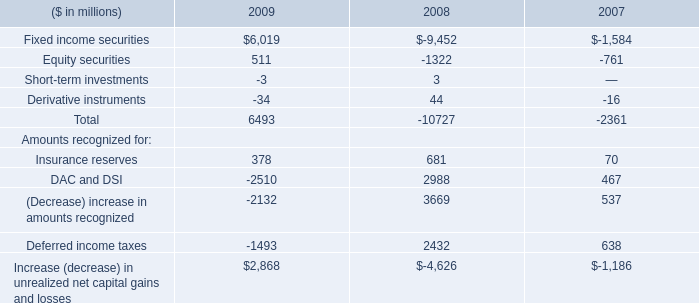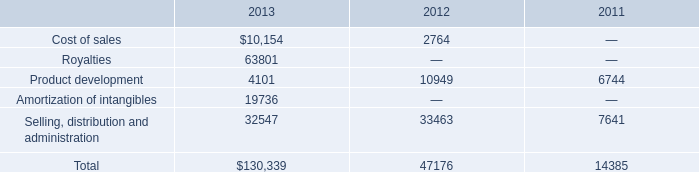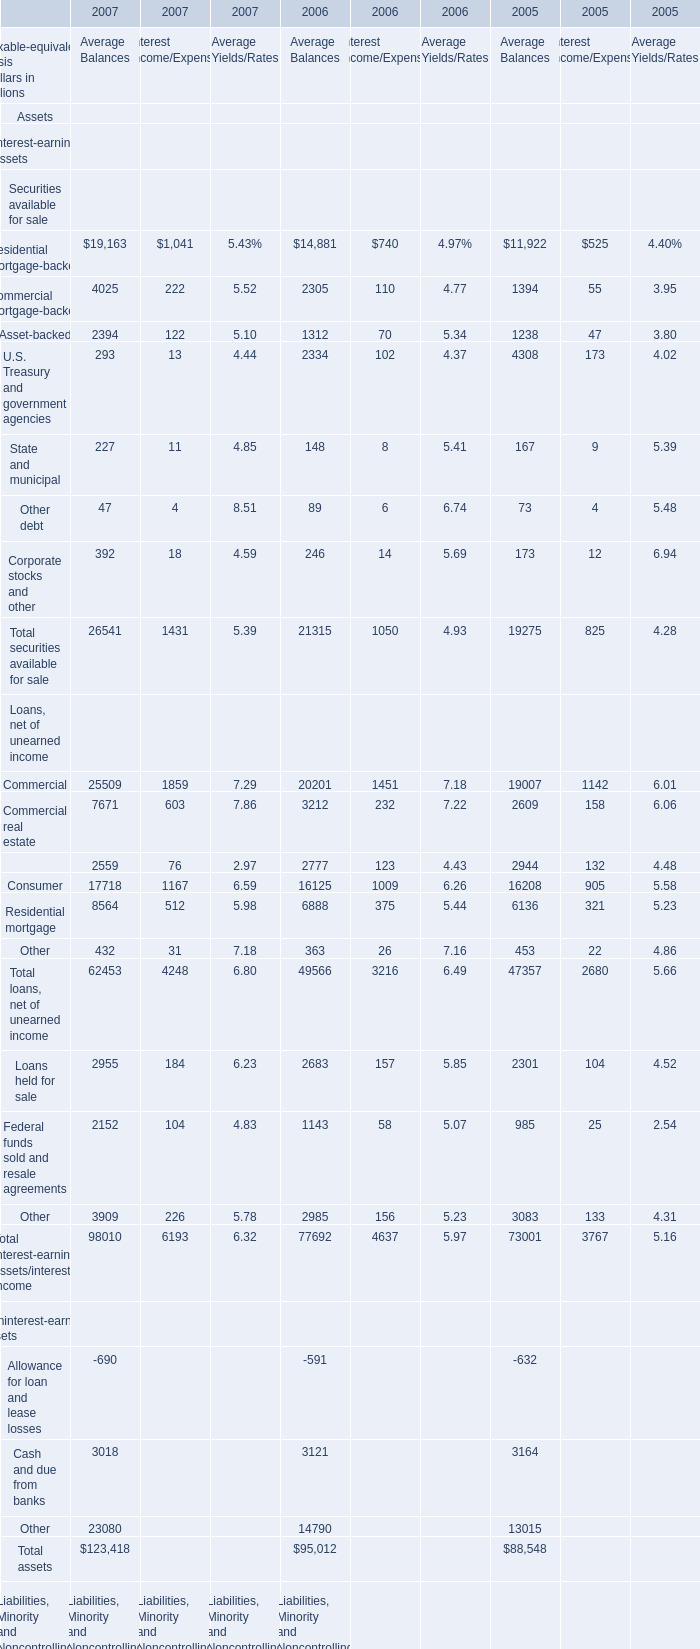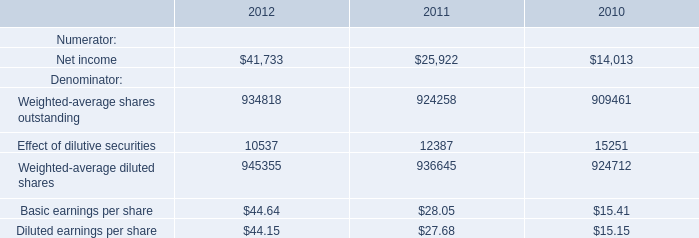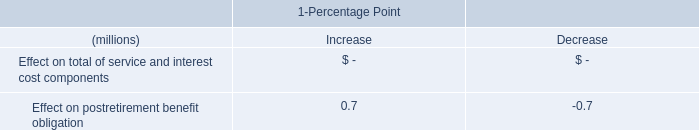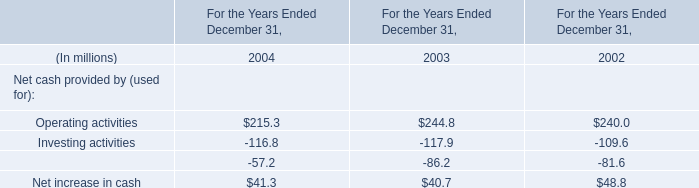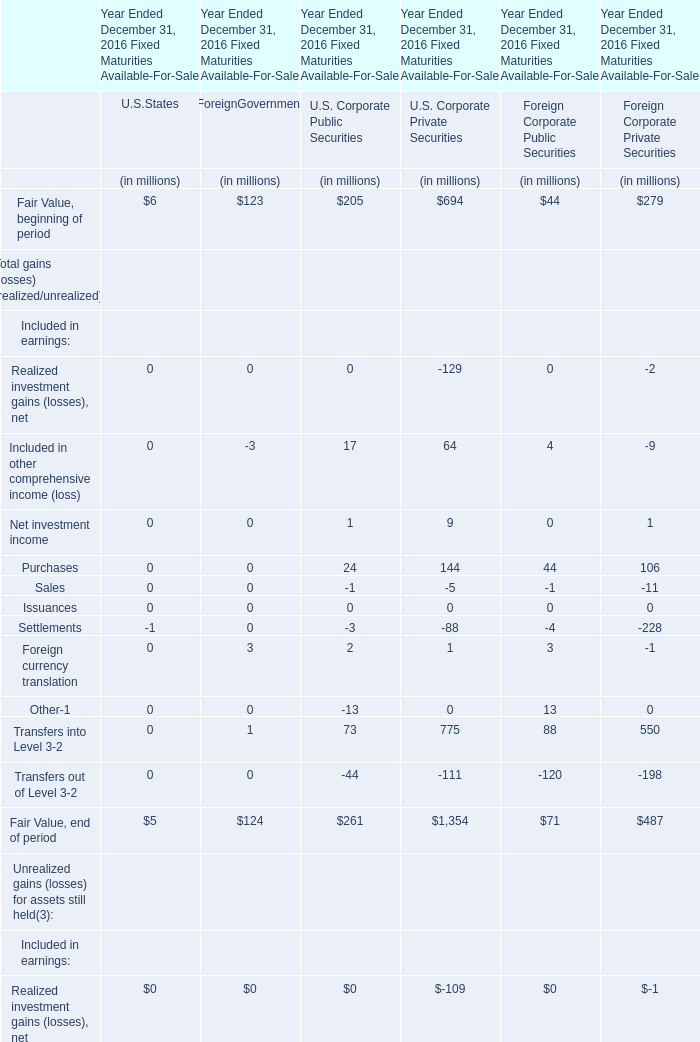What is the average amount of Equity securities of 2008, and Federal funds purchased Borrowed funds of 2005 Average Balances ? 
Computations: ((1322.0 + 2098.0) / 2)
Answer: 1710.0. 